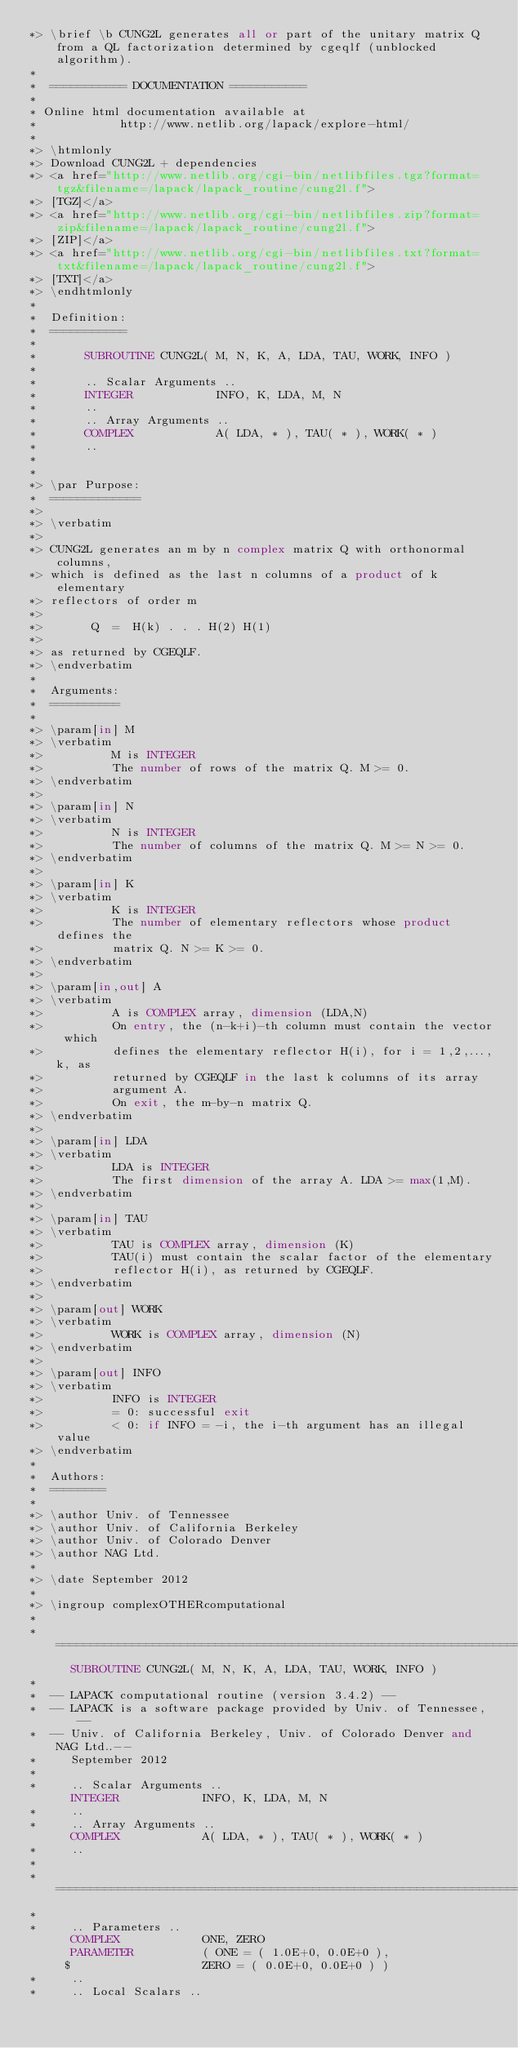<code> <loc_0><loc_0><loc_500><loc_500><_FORTRAN_>*> \brief \b CUNG2L generates all or part of the unitary matrix Q from a QL factorization determined by cgeqlf (unblocked algorithm).
*
*  =========== DOCUMENTATION ===========
*
* Online html documentation available at 
*            http://www.netlib.org/lapack/explore-html/ 
*
*> \htmlonly
*> Download CUNG2L + dependencies 
*> <a href="http://www.netlib.org/cgi-bin/netlibfiles.tgz?format=tgz&filename=/lapack/lapack_routine/cung2l.f"> 
*> [TGZ]</a> 
*> <a href="http://www.netlib.org/cgi-bin/netlibfiles.zip?format=zip&filename=/lapack/lapack_routine/cung2l.f"> 
*> [ZIP]</a> 
*> <a href="http://www.netlib.org/cgi-bin/netlibfiles.txt?format=txt&filename=/lapack/lapack_routine/cung2l.f"> 
*> [TXT]</a>
*> \endhtmlonly 
*
*  Definition:
*  ===========
*
*       SUBROUTINE CUNG2L( M, N, K, A, LDA, TAU, WORK, INFO )
* 
*       .. Scalar Arguments ..
*       INTEGER            INFO, K, LDA, M, N
*       ..
*       .. Array Arguments ..
*       COMPLEX            A( LDA, * ), TAU( * ), WORK( * )
*       ..
*  
*
*> \par Purpose:
*  =============
*>
*> \verbatim
*>
*> CUNG2L generates an m by n complex matrix Q with orthonormal columns,
*> which is defined as the last n columns of a product of k elementary
*> reflectors of order m
*>
*>       Q  =  H(k) . . . H(2) H(1)
*>
*> as returned by CGEQLF.
*> \endverbatim
*
*  Arguments:
*  ==========
*
*> \param[in] M
*> \verbatim
*>          M is INTEGER
*>          The number of rows of the matrix Q. M >= 0.
*> \endverbatim
*>
*> \param[in] N
*> \verbatim
*>          N is INTEGER
*>          The number of columns of the matrix Q. M >= N >= 0.
*> \endverbatim
*>
*> \param[in] K
*> \verbatim
*>          K is INTEGER
*>          The number of elementary reflectors whose product defines the
*>          matrix Q. N >= K >= 0.
*> \endverbatim
*>
*> \param[in,out] A
*> \verbatim
*>          A is COMPLEX array, dimension (LDA,N)
*>          On entry, the (n-k+i)-th column must contain the vector which
*>          defines the elementary reflector H(i), for i = 1,2,...,k, as
*>          returned by CGEQLF in the last k columns of its array
*>          argument A.
*>          On exit, the m-by-n matrix Q.
*> \endverbatim
*>
*> \param[in] LDA
*> \verbatim
*>          LDA is INTEGER
*>          The first dimension of the array A. LDA >= max(1,M).
*> \endverbatim
*>
*> \param[in] TAU
*> \verbatim
*>          TAU is COMPLEX array, dimension (K)
*>          TAU(i) must contain the scalar factor of the elementary
*>          reflector H(i), as returned by CGEQLF.
*> \endverbatim
*>
*> \param[out] WORK
*> \verbatim
*>          WORK is COMPLEX array, dimension (N)
*> \endverbatim
*>
*> \param[out] INFO
*> \verbatim
*>          INFO is INTEGER
*>          = 0: successful exit
*>          < 0: if INFO = -i, the i-th argument has an illegal value
*> \endverbatim
*
*  Authors:
*  ========
*
*> \author Univ. of Tennessee 
*> \author Univ. of California Berkeley 
*> \author Univ. of Colorado Denver 
*> \author NAG Ltd. 
*
*> \date September 2012
*
*> \ingroup complexOTHERcomputational
*
*  =====================================================================
      SUBROUTINE CUNG2L( M, N, K, A, LDA, TAU, WORK, INFO )
*
*  -- LAPACK computational routine (version 3.4.2) --
*  -- LAPACK is a software package provided by Univ. of Tennessee,    --
*  -- Univ. of California Berkeley, Univ. of Colorado Denver and NAG Ltd..--
*     September 2012
*
*     .. Scalar Arguments ..
      INTEGER            INFO, K, LDA, M, N
*     ..
*     .. Array Arguments ..
      COMPLEX            A( LDA, * ), TAU( * ), WORK( * )
*     ..
*
*  =====================================================================
*
*     .. Parameters ..
      COMPLEX            ONE, ZERO
      PARAMETER          ( ONE = ( 1.0E+0, 0.0E+0 ),
     $                   ZERO = ( 0.0E+0, 0.0E+0 ) )
*     ..
*     .. Local Scalars ..</code> 